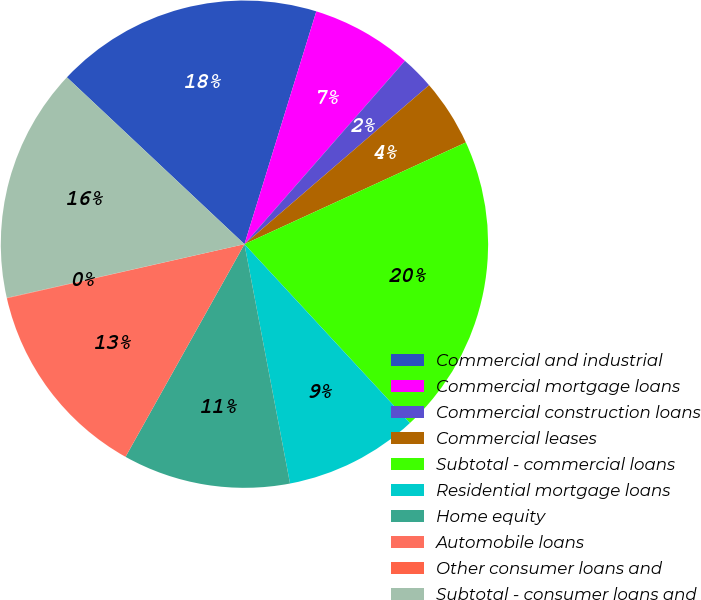Convert chart. <chart><loc_0><loc_0><loc_500><loc_500><pie_chart><fcel>Commercial and industrial<fcel>Commercial mortgage loans<fcel>Commercial construction loans<fcel>Commercial leases<fcel>Subtotal - commercial loans<fcel>Residential mortgage loans<fcel>Home equity<fcel>Automobile loans<fcel>Other consumer loans and<fcel>Subtotal - consumer loans and<nl><fcel>17.76%<fcel>6.68%<fcel>2.24%<fcel>4.46%<fcel>19.97%<fcel>8.89%<fcel>11.11%<fcel>13.32%<fcel>0.03%<fcel>15.54%<nl></chart> 